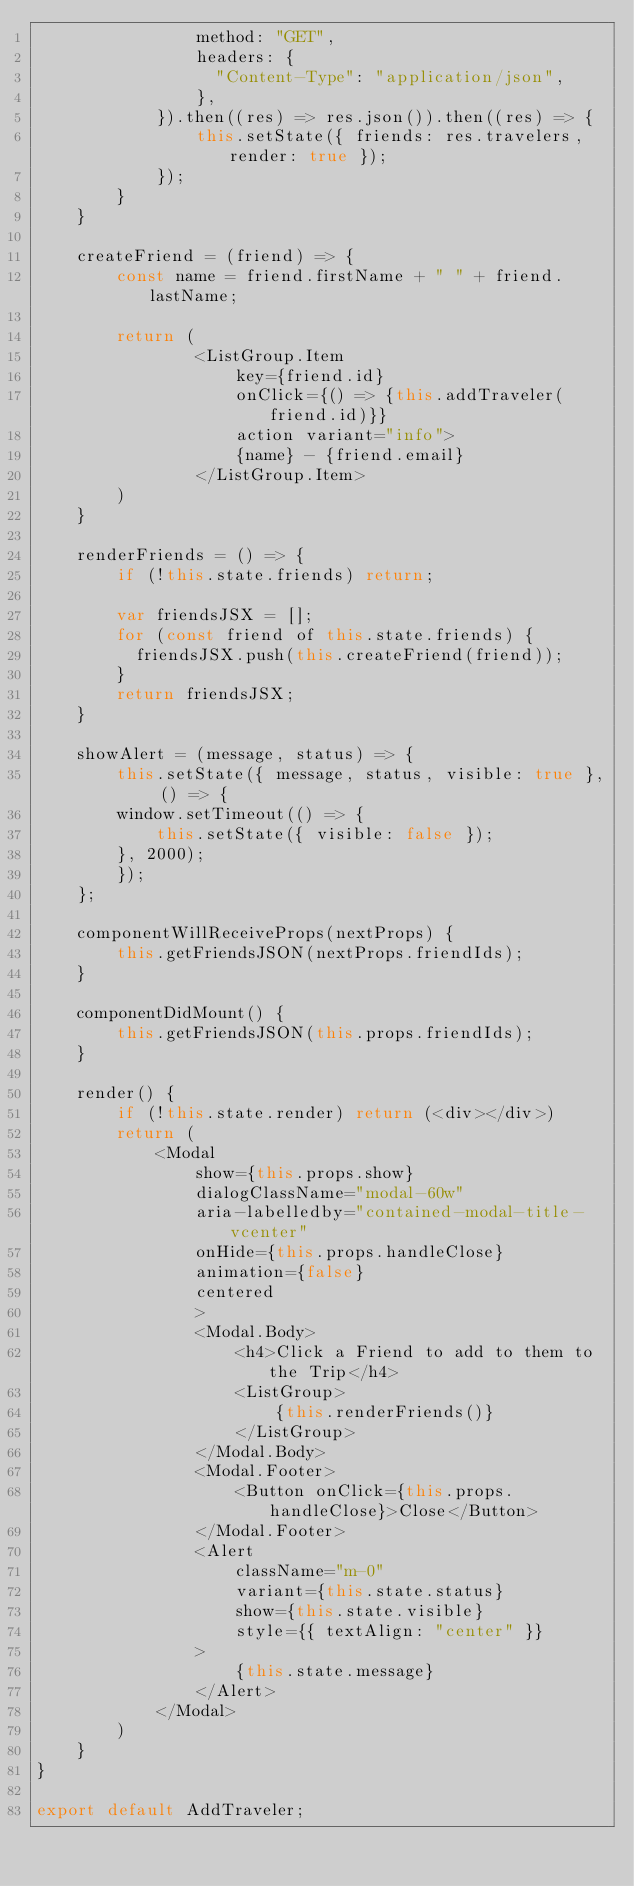Convert code to text. <code><loc_0><loc_0><loc_500><loc_500><_JavaScript_>                method: "GET",
                headers: {
                  "Content-Type": "application/json",
                },
            }).then((res) => res.json()).then((res) => {
                this.setState({ friends: res.travelers, render: true });
            });
        }
    }

    createFriend = (friend) => {
        const name = friend.firstName + " " + friend.lastName;

        return (
                <ListGroup.Item 
                    key={friend.id}
                    onClick={() => {this.addTraveler(friend.id)}}
                    action variant="info">
                    {name} - {friend.email}
                </ListGroup.Item>
        )
    }

    renderFriends = () => {
        if (!this.state.friends) return;

        var friendsJSX = [];
        for (const friend of this.state.friends) {
          friendsJSX.push(this.createFriend(friend));
        }
        return friendsJSX;
    }

    showAlert = (message, status) => {
        this.setState({ message, status, visible: true }, () => {
        window.setTimeout(() => {
            this.setState({ visible: false });
        }, 2000);
        });
    };

    componentWillReceiveProps(nextProps) {
        this.getFriendsJSON(nextProps.friendIds);
    }

    componentDidMount() {
        this.getFriendsJSON(this.props.friendIds);
    }

    render() {
        if (!this.state.render) return (<div></div>)
        return (
            <Modal
                show={this.props.show}
                dialogClassName="modal-60w"
                aria-labelledby="contained-modal-title-vcenter"
                onHide={this.props.handleClose}
                animation={false}
                centered
                >
                <Modal.Body>
                    <h4>Click a Friend to add to them to the Trip</h4>
                    <ListGroup> 
                        {this.renderFriends()}
                    </ListGroup>
                </Modal.Body>
                <Modal.Footer>
                    <Button onClick={this.props.handleClose}>Close</Button>
                </Modal.Footer>
                <Alert
                    className="m-0"
                    variant={this.state.status}
                    show={this.state.visible}
                    style={{ textAlign: "center" }}
                >
                    {this.state.message}
                </Alert>
            </Modal>
        )
    }
}

export default AddTraveler;

</code> 